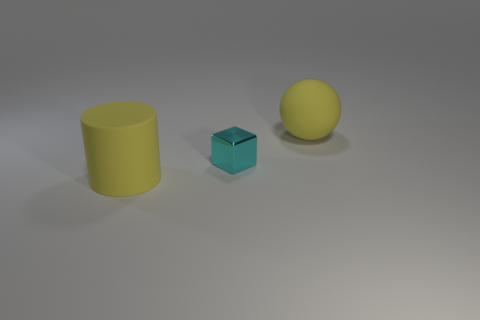What size is the cylinder that is the same color as the rubber sphere?
Provide a short and direct response. Large. There is a yellow thing left of the large yellow matte thing on the right side of the yellow cylinder; what shape is it?
Provide a short and direct response. Cylinder. There is a small thing; does it have the same shape as the yellow matte object on the left side of the large sphere?
Provide a succinct answer. No. What color is the rubber thing that is the same size as the yellow cylinder?
Your answer should be very brief. Yellow. Are there fewer small cyan things that are behind the tiny shiny block than tiny shiny objects behind the yellow rubber sphere?
Your response must be concise. No. The matte thing to the left of the rubber object that is on the right side of the thing in front of the cyan shiny block is what shape?
Your response must be concise. Cylinder. There is a large thing that is behind the cube; is it the same color as the matte thing left of the cyan block?
Keep it short and to the point. Yes. What shape is the rubber thing that is the same color as the large matte ball?
Provide a succinct answer. Cylinder. What number of metal things are either tiny things or cylinders?
Provide a short and direct response. 1. The big matte object that is on the right side of the matte thing left of the yellow sphere behind the big matte cylinder is what color?
Make the answer very short. Yellow. 